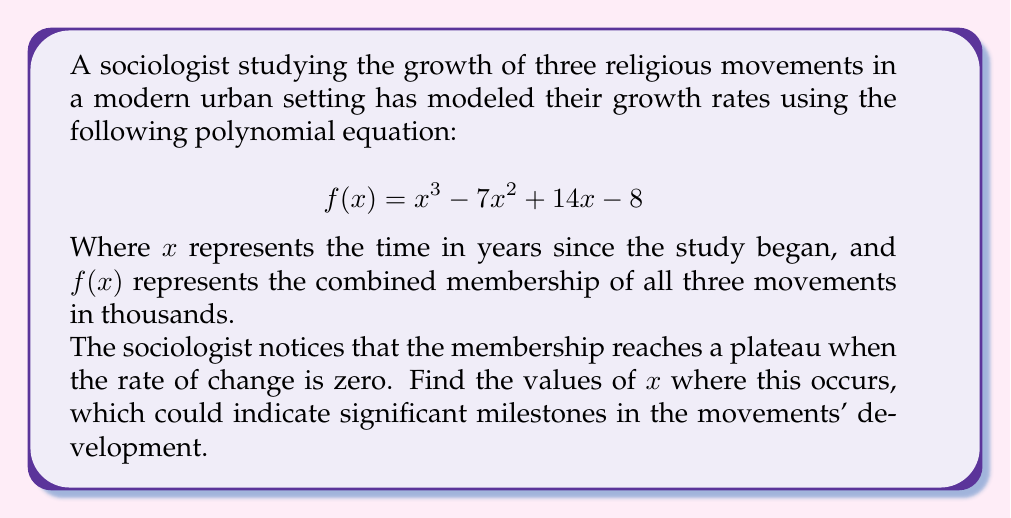Solve this math problem. To solve this problem, we need to find the roots of the derivative of $f(x)$, as these represent the points where the rate of change is zero.

1) First, let's find the derivative of $f(x)$:
   $$ f'(x) = 3x^2 - 14x + 14 $$

2) Now, we need to solve the equation $f'(x) = 0$:
   $$ 3x^2 - 14x + 14 = 0 $$

3) This is a quadratic equation. We can solve it using the quadratic formula:
   $$ x = \frac{-b \pm \sqrt{b^2 - 4ac}}{2a} $$
   Where $a = 3$, $b = -14$, and $c = 14$

4) Substituting these values:
   $$ x = \frac{14 \pm \sqrt{(-14)^2 - 4(3)(14)}}{2(3)} $$
   $$ x = \frac{14 \pm \sqrt{196 - 168}}{6} $$
   $$ x = \frac{14 \pm \sqrt{28}}{6} $$
   $$ x = \frac{14 \pm 2\sqrt{7}}{6} $$

5) Simplifying:
   $$ x = \frac{7 \pm \sqrt{7}}{3} $$

Therefore, the rate of change is zero at two points:
$$ x_1 = \frac{7 + \sqrt{7}}{3} \approx 3.55 \text{ years} $$
$$ x_2 = \frac{7 - \sqrt{7}}{3} \approx 1.12 \text{ years} $$

These points represent times when the combined membership growth of the three religious movements reaches a plateau, which could indicate significant milestones in their development within the modern urban setting.
Answer: The membership growth reaches a plateau at approximately 1.12 years and 3.55 years after the start of the study. 